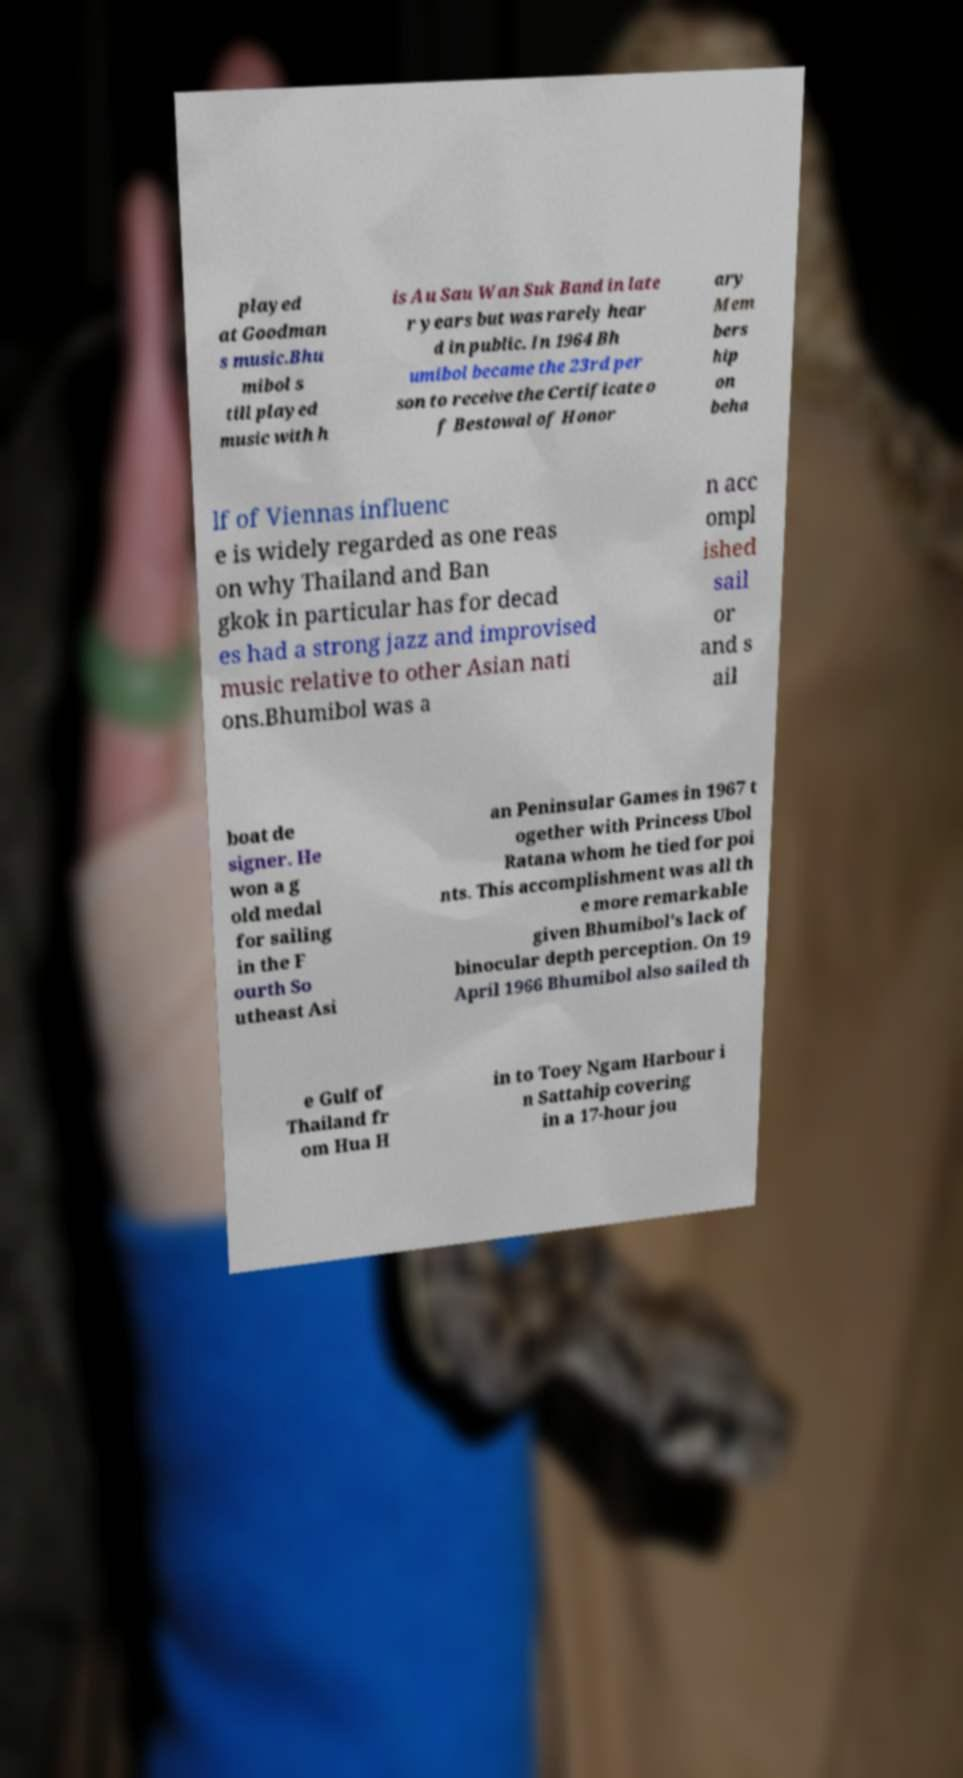Can you accurately transcribe the text from the provided image for me? played at Goodman s music.Bhu mibol s till played music with h is Au Sau Wan Suk Band in late r years but was rarely hear d in public. In 1964 Bh umibol became the 23rd per son to receive the Certificate o f Bestowal of Honor ary Mem bers hip on beha lf of Viennas influenc e is widely regarded as one reas on why Thailand and Ban gkok in particular has for decad es had a strong jazz and improvised music relative to other Asian nati ons.Bhumibol was a n acc ompl ished sail or and s ail boat de signer. He won a g old medal for sailing in the F ourth So utheast Asi an Peninsular Games in 1967 t ogether with Princess Ubol Ratana whom he tied for poi nts. This accomplishment was all th e more remarkable given Bhumibol's lack of binocular depth perception. On 19 April 1966 Bhumibol also sailed th e Gulf of Thailand fr om Hua H in to Toey Ngam Harbour i n Sattahip covering in a 17-hour jou 